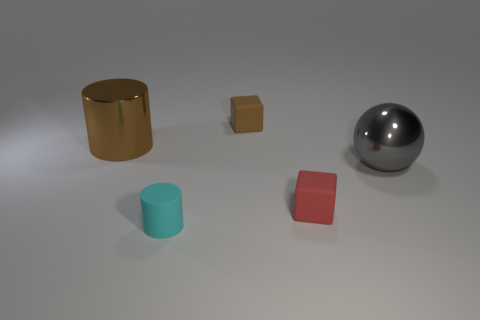Add 4 tiny cylinders. How many objects exist? 9 Subtract all cubes. How many objects are left? 3 Subtract 0 gray cubes. How many objects are left? 5 Subtract all big shiny spheres. Subtract all tiny rubber cylinders. How many objects are left? 3 Add 4 tiny rubber cylinders. How many tiny rubber cylinders are left? 5 Add 4 big cyan blocks. How many big cyan blocks exist? 4 